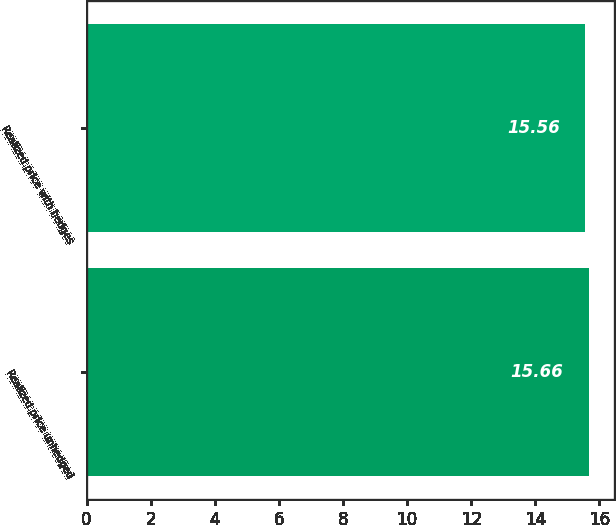Convert chart to OTSL. <chart><loc_0><loc_0><loc_500><loc_500><bar_chart><fcel>Realized price unhedged<fcel>Realized price with hedges<nl><fcel>15.66<fcel>15.56<nl></chart> 